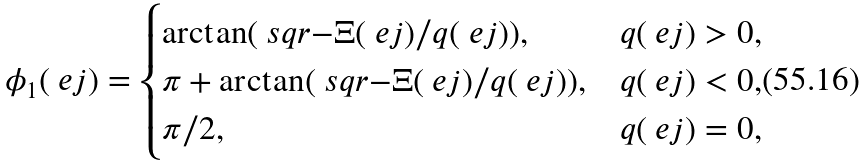<formula> <loc_0><loc_0><loc_500><loc_500>\phi _ { 1 } ( \ e j ) = \begin{cases} \arctan ( \ s q r { - \Xi ( \ e j ) } / q ( \ e j ) ) , & q ( \ e j ) > 0 , \\ \pi + \arctan ( \ s q r { - \Xi ( \ e j ) } / q ( \ e j ) ) , & q ( \ e j ) < 0 , \\ \pi / 2 , & q ( \ e j ) = 0 , \end{cases}</formula> 